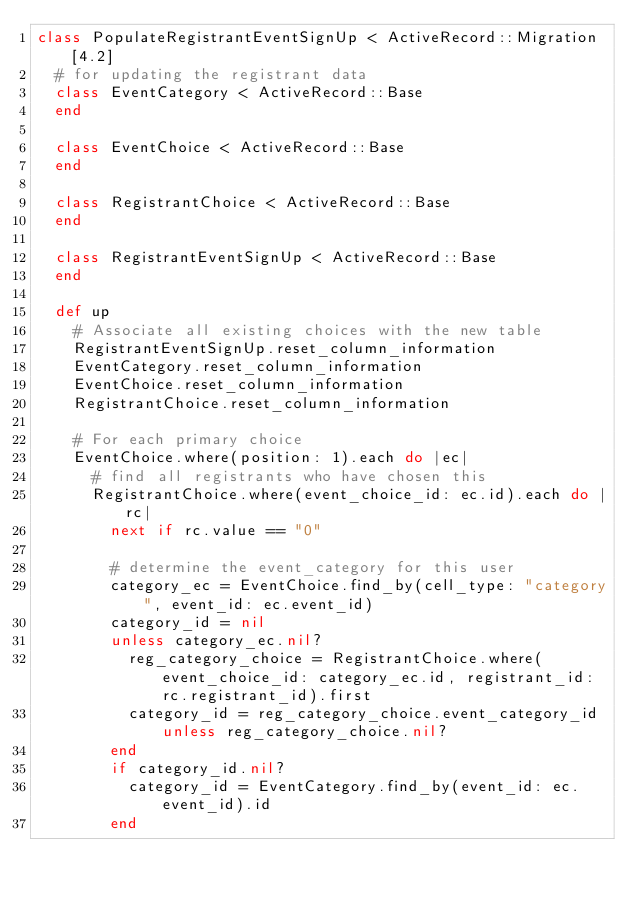<code> <loc_0><loc_0><loc_500><loc_500><_Ruby_>class PopulateRegistrantEventSignUp < ActiveRecord::Migration[4.2]
  # for updating the registrant data
  class EventCategory < ActiveRecord::Base
  end

  class EventChoice < ActiveRecord::Base
  end

  class RegistrantChoice < ActiveRecord::Base
  end

  class RegistrantEventSignUp < ActiveRecord::Base
  end

  def up
    # Associate all existing choices with the new table
    RegistrantEventSignUp.reset_column_information
    EventCategory.reset_column_information
    EventChoice.reset_column_information
    RegistrantChoice.reset_column_information

    # For each primary choice
    EventChoice.where(position: 1).each do |ec|
      # find all registrants who have chosen this
      RegistrantChoice.where(event_choice_id: ec.id).each do |rc|
        next if rc.value == "0"

        # determine the event_category for this user
        category_ec = EventChoice.find_by(cell_type: "category", event_id: ec.event_id)
        category_id = nil
        unless category_ec.nil?
          reg_category_choice = RegistrantChoice.where(event_choice_id: category_ec.id, registrant_id: rc.registrant_id).first
          category_id = reg_category_choice.event_category_id unless reg_category_choice.nil?
        end
        if category_id.nil?
          category_id = EventCategory.find_by(event_id: ec.event_id).id
        end
</code> 